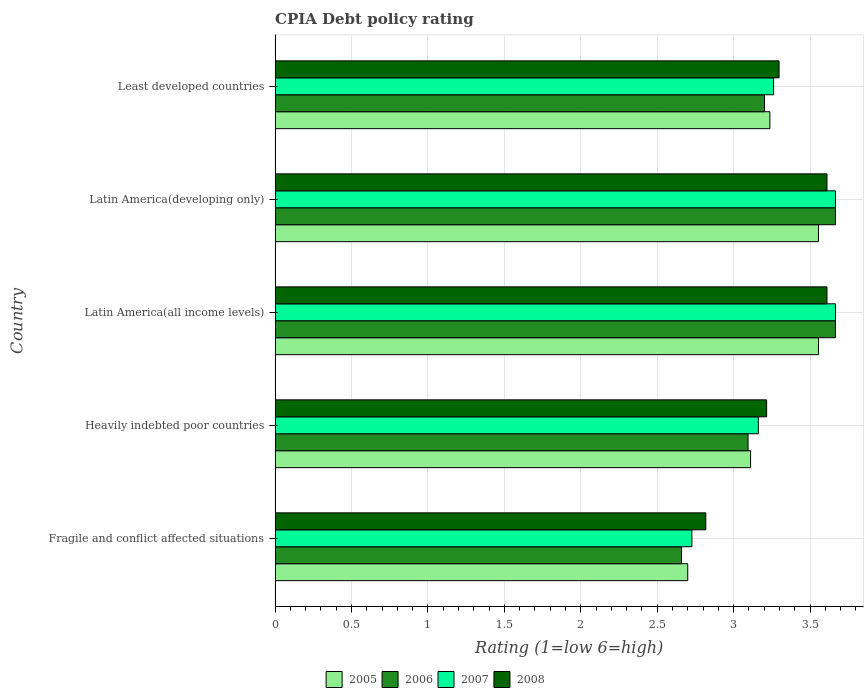How many different coloured bars are there?
Give a very brief answer. 4. How many groups of bars are there?
Your response must be concise. 5. How many bars are there on the 1st tick from the top?
Give a very brief answer. 4. How many bars are there on the 2nd tick from the bottom?
Provide a short and direct response. 4. What is the label of the 2nd group of bars from the top?
Provide a succinct answer. Latin America(developing only). In how many cases, is the number of bars for a given country not equal to the number of legend labels?
Your answer should be very brief. 0. What is the CPIA rating in 2008 in Fragile and conflict affected situations?
Make the answer very short. 2.82. Across all countries, what is the maximum CPIA rating in 2005?
Make the answer very short. 3.56. Across all countries, what is the minimum CPIA rating in 2006?
Provide a succinct answer. 2.66. In which country was the CPIA rating in 2008 maximum?
Your response must be concise. Latin America(all income levels). In which country was the CPIA rating in 2007 minimum?
Your response must be concise. Fragile and conflict affected situations. What is the total CPIA rating in 2006 in the graph?
Ensure brevity in your answer.  16.29. What is the difference between the CPIA rating in 2008 in Latin America(developing only) and that in Least developed countries?
Keep it short and to the point. 0.31. What is the difference between the CPIA rating in 2006 in Heavily indebted poor countries and the CPIA rating in 2007 in Latin America(all income levels)?
Your answer should be compact. -0.57. What is the average CPIA rating in 2006 per country?
Your answer should be very brief. 3.26. What is the difference between the CPIA rating in 2005 and CPIA rating in 2007 in Latin America(developing only)?
Provide a short and direct response. -0.11. What is the ratio of the CPIA rating in 2005 in Fragile and conflict affected situations to that in Least developed countries?
Your answer should be very brief. 0.83. Is the difference between the CPIA rating in 2005 in Fragile and conflict affected situations and Least developed countries greater than the difference between the CPIA rating in 2007 in Fragile and conflict affected situations and Least developed countries?
Your answer should be compact. No. What is the difference between the highest and the second highest CPIA rating in 2008?
Give a very brief answer. 0. What is the difference between the highest and the lowest CPIA rating in 2007?
Provide a short and direct response. 0.94. Is the sum of the CPIA rating in 2006 in Fragile and conflict affected situations and Latin America(developing only) greater than the maximum CPIA rating in 2005 across all countries?
Provide a succinct answer. Yes. Is it the case that in every country, the sum of the CPIA rating in 2008 and CPIA rating in 2005 is greater than the sum of CPIA rating in 2006 and CPIA rating in 2007?
Your answer should be compact. No. Is it the case that in every country, the sum of the CPIA rating in 2008 and CPIA rating in 2007 is greater than the CPIA rating in 2005?
Offer a terse response. Yes. Are all the bars in the graph horizontal?
Your answer should be compact. Yes. Where does the legend appear in the graph?
Your answer should be very brief. Bottom center. How are the legend labels stacked?
Make the answer very short. Horizontal. What is the title of the graph?
Keep it short and to the point. CPIA Debt policy rating. What is the label or title of the Y-axis?
Make the answer very short. Country. What is the Rating (1=low 6=high) of 2006 in Fragile and conflict affected situations?
Keep it short and to the point. 2.66. What is the Rating (1=low 6=high) of 2007 in Fragile and conflict affected situations?
Keep it short and to the point. 2.73. What is the Rating (1=low 6=high) in 2008 in Fragile and conflict affected situations?
Give a very brief answer. 2.82. What is the Rating (1=low 6=high) in 2005 in Heavily indebted poor countries?
Give a very brief answer. 3.11. What is the Rating (1=low 6=high) of 2006 in Heavily indebted poor countries?
Provide a short and direct response. 3.09. What is the Rating (1=low 6=high) in 2007 in Heavily indebted poor countries?
Provide a short and direct response. 3.16. What is the Rating (1=low 6=high) of 2008 in Heavily indebted poor countries?
Offer a terse response. 3.22. What is the Rating (1=low 6=high) of 2005 in Latin America(all income levels)?
Make the answer very short. 3.56. What is the Rating (1=low 6=high) in 2006 in Latin America(all income levels)?
Offer a terse response. 3.67. What is the Rating (1=low 6=high) of 2007 in Latin America(all income levels)?
Give a very brief answer. 3.67. What is the Rating (1=low 6=high) of 2008 in Latin America(all income levels)?
Offer a very short reply. 3.61. What is the Rating (1=low 6=high) in 2005 in Latin America(developing only)?
Provide a short and direct response. 3.56. What is the Rating (1=low 6=high) of 2006 in Latin America(developing only)?
Make the answer very short. 3.67. What is the Rating (1=low 6=high) of 2007 in Latin America(developing only)?
Give a very brief answer. 3.67. What is the Rating (1=low 6=high) in 2008 in Latin America(developing only)?
Offer a very short reply. 3.61. What is the Rating (1=low 6=high) of 2005 in Least developed countries?
Offer a very short reply. 3.24. What is the Rating (1=low 6=high) in 2006 in Least developed countries?
Provide a short and direct response. 3.2. What is the Rating (1=low 6=high) in 2007 in Least developed countries?
Provide a short and direct response. 3.26. What is the Rating (1=low 6=high) in 2008 in Least developed countries?
Keep it short and to the point. 3.3. Across all countries, what is the maximum Rating (1=low 6=high) in 2005?
Ensure brevity in your answer.  3.56. Across all countries, what is the maximum Rating (1=low 6=high) in 2006?
Make the answer very short. 3.67. Across all countries, what is the maximum Rating (1=low 6=high) in 2007?
Ensure brevity in your answer.  3.67. Across all countries, what is the maximum Rating (1=low 6=high) of 2008?
Your answer should be compact. 3.61. Across all countries, what is the minimum Rating (1=low 6=high) in 2005?
Give a very brief answer. 2.7. Across all countries, what is the minimum Rating (1=low 6=high) in 2006?
Keep it short and to the point. 2.66. Across all countries, what is the minimum Rating (1=low 6=high) in 2007?
Your answer should be very brief. 2.73. Across all countries, what is the minimum Rating (1=low 6=high) in 2008?
Your response must be concise. 2.82. What is the total Rating (1=low 6=high) in 2005 in the graph?
Keep it short and to the point. 16.16. What is the total Rating (1=low 6=high) in 2006 in the graph?
Your answer should be very brief. 16.29. What is the total Rating (1=low 6=high) in 2007 in the graph?
Make the answer very short. 16.48. What is the total Rating (1=low 6=high) of 2008 in the graph?
Give a very brief answer. 16.55. What is the difference between the Rating (1=low 6=high) of 2005 in Fragile and conflict affected situations and that in Heavily indebted poor countries?
Your answer should be very brief. -0.41. What is the difference between the Rating (1=low 6=high) in 2006 in Fragile and conflict affected situations and that in Heavily indebted poor countries?
Offer a terse response. -0.44. What is the difference between the Rating (1=low 6=high) in 2007 in Fragile and conflict affected situations and that in Heavily indebted poor countries?
Provide a succinct answer. -0.43. What is the difference between the Rating (1=low 6=high) of 2008 in Fragile and conflict affected situations and that in Heavily indebted poor countries?
Provide a short and direct response. -0.4. What is the difference between the Rating (1=low 6=high) in 2005 in Fragile and conflict affected situations and that in Latin America(all income levels)?
Provide a succinct answer. -0.86. What is the difference between the Rating (1=low 6=high) of 2006 in Fragile and conflict affected situations and that in Latin America(all income levels)?
Ensure brevity in your answer.  -1.01. What is the difference between the Rating (1=low 6=high) of 2007 in Fragile and conflict affected situations and that in Latin America(all income levels)?
Offer a very short reply. -0.94. What is the difference between the Rating (1=low 6=high) of 2008 in Fragile and conflict affected situations and that in Latin America(all income levels)?
Make the answer very short. -0.79. What is the difference between the Rating (1=low 6=high) of 2005 in Fragile and conflict affected situations and that in Latin America(developing only)?
Your response must be concise. -0.86. What is the difference between the Rating (1=low 6=high) in 2006 in Fragile and conflict affected situations and that in Latin America(developing only)?
Your answer should be compact. -1.01. What is the difference between the Rating (1=low 6=high) in 2007 in Fragile and conflict affected situations and that in Latin America(developing only)?
Give a very brief answer. -0.94. What is the difference between the Rating (1=low 6=high) in 2008 in Fragile and conflict affected situations and that in Latin America(developing only)?
Make the answer very short. -0.79. What is the difference between the Rating (1=low 6=high) in 2005 in Fragile and conflict affected situations and that in Least developed countries?
Your answer should be very brief. -0.54. What is the difference between the Rating (1=low 6=high) in 2006 in Fragile and conflict affected situations and that in Least developed countries?
Your response must be concise. -0.54. What is the difference between the Rating (1=low 6=high) of 2007 in Fragile and conflict affected situations and that in Least developed countries?
Provide a short and direct response. -0.53. What is the difference between the Rating (1=low 6=high) of 2008 in Fragile and conflict affected situations and that in Least developed countries?
Your answer should be compact. -0.48. What is the difference between the Rating (1=low 6=high) in 2005 in Heavily indebted poor countries and that in Latin America(all income levels)?
Give a very brief answer. -0.44. What is the difference between the Rating (1=low 6=high) of 2006 in Heavily indebted poor countries and that in Latin America(all income levels)?
Ensure brevity in your answer.  -0.57. What is the difference between the Rating (1=low 6=high) in 2007 in Heavily indebted poor countries and that in Latin America(all income levels)?
Your answer should be very brief. -0.5. What is the difference between the Rating (1=low 6=high) in 2008 in Heavily indebted poor countries and that in Latin America(all income levels)?
Your answer should be very brief. -0.39. What is the difference between the Rating (1=low 6=high) in 2005 in Heavily indebted poor countries and that in Latin America(developing only)?
Give a very brief answer. -0.44. What is the difference between the Rating (1=low 6=high) in 2006 in Heavily indebted poor countries and that in Latin America(developing only)?
Offer a terse response. -0.57. What is the difference between the Rating (1=low 6=high) in 2007 in Heavily indebted poor countries and that in Latin America(developing only)?
Give a very brief answer. -0.5. What is the difference between the Rating (1=low 6=high) of 2008 in Heavily indebted poor countries and that in Latin America(developing only)?
Your answer should be very brief. -0.39. What is the difference between the Rating (1=low 6=high) in 2005 in Heavily indebted poor countries and that in Least developed countries?
Offer a terse response. -0.13. What is the difference between the Rating (1=low 6=high) of 2006 in Heavily indebted poor countries and that in Least developed countries?
Provide a short and direct response. -0.11. What is the difference between the Rating (1=low 6=high) of 2007 in Heavily indebted poor countries and that in Least developed countries?
Your response must be concise. -0.1. What is the difference between the Rating (1=low 6=high) in 2008 in Heavily indebted poor countries and that in Least developed countries?
Make the answer very short. -0.08. What is the difference between the Rating (1=low 6=high) in 2006 in Latin America(all income levels) and that in Latin America(developing only)?
Offer a terse response. 0. What is the difference between the Rating (1=low 6=high) of 2007 in Latin America(all income levels) and that in Latin America(developing only)?
Keep it short and to the point. 0. What is the difference between the Rating (1=low 6=high) of 2008 in Latin America(all income levels) and that in Latin America(developing only)?
Give a very brief answer. 0. What is the difference between the Rating (1=low 6=high) in 2005 in Latin America(all income levels) and that in Least developed countries?
Keep it short and to the point. 0.32. What is the difference between the Rating (1=low 6=high) in 2006 in Latin America(all income levels) and that in Least developed countries?
Your response must be concise. 0.46. What is the difference between the Rating (1=low 6=high) of 2007 in Latin America(all income levels) and that in Least developed countries?
Keep it short and to the point. 0.4. What is the difference between the Rating (1=low 6=high) in 2008 in Latin America(all income levels) and that in Least developed countries?
Your answer should be very brief. 0.31. What is the difference between the Rating (1=low 6=high) of 2005 in Latin America(developing only) and that in Least developed countries?
Your answer should be compact. 0.32. What is the difference between the Rating (1=low 6=high) in 2006 in Latin America(developing only) and that in Least developed countries?
Provide a short and direct response. 0.46. What is the difference between the Rating (1=low 6=high) of 2007 in Latin America(developing only) and that in Least developed countries?
Provide a succinct answer. 0.4. What is the difference between the Rating (1=low 6=high) of 2008 in Latin America(developing only) and that in Least developed countries?
Your answer should be very brief. 0.31. What is the difference between the Rating (1=low 6=high) in 2005 in Fragile and conflict affected situations and the Rating (1=low 6=high) in 2006 in Heavily indebted poor countries?
Give a very brief answer. -0.39. What is the difference between the Rating (1=low 6=high) of 2005 in Fragile and conflict affected situations and the Rating (1=low 6=high) of 2007 in Heavily indebted poor countries?
Your answer should be compact. -0.46. What is the difference between the Rating (1=low 6=high) of 2005 in Fragile and conflict affected situations and the Rating (1=low 6=high) of 2008 in Heavily indebted poor countries?
Offer a very short reply. -0.52. What is the difference between the Rating (1=low 6=high) of 2006 in Fragile and conflict affected situations and the Rating (1=low 6=high) of 2007 in Heavily indebted poor countries?
Give a very brief answer. -0.5. What is the difference between the Rating (1=low 6=high) of 2006 in Fragile and conflict affected situations and the Rating (1=low 6=high) of 2008 in Heavily indebted poor countries?
Offer a terse response. -0.56. What is the difference between the Rating (1=low 6=high) in 2007 in Fragile and conflict affected situations and the Rating (1=low 6=high) in 2008 in Heavily indebted poor countries?
Keep it short and to the point. -0.49. What is the difference between the Rating (1=low 6=high) in 2005 in Fragile and conflict affected situations and the Rating (1=low 6=high) in 2006 in Latin America(all income levels)?
Offer a very short reply. -0.97. What is the difference between the Rating (1=low 6=high) of 2005 in Fragile and conflict affected situations and the Rating (1=low 6=high) of 2007 in Latin America(all income levels)?
Offer a terse response. -0.97. What is the difference between the Rating (1=low 6=high) of 2005 in Fragile and conflict affected situations and the Rating (1=low 6=high) of 2008 in Latin America(all income levels)?
Offer a very short reply. -0.91. What is the difference between the Rating (1=low 6=high) in 2006 in Fragile and conflict affected situations and the Rating (1=low 6=high) in 2007 in Latin America(all income levels)?
Provide a short and direct response. -1.01. What is the difference between the Rating (1=low 6=high) in 2006 in Fragile and conflict affected situations and the Rating (1=low 6=high) in 2008 in Latin America(all income levels)?
Give a very brief answer. -0.95. What is the difference between the Rating (1=low 6=high) of 2007 in Fragile and conflict affected situations and the Rating (1=low 6=high) of 2008 in Latin America(all income levels)?
Offer a terse response. -0.88. What is the difference between the Rating (1=low 6=high) of 2005 in Fragile and conflict affected situations and the Rating (1=low 6=high) of 2006 in Latin America(developing only)?
Make the answer very short. -0.97. What is the difference between the Rating (1=low 6=high) in 2005 in Fragile and conflict affected situations and the Rating (1=low 6=high) in 2007 in Latin America(developing only)?
Give a very brief answer. -0.97. What is the difference between the Rating (1=low 6=high) of 2005 in Fragile and conflict affected situations and the Rating (1=low 6=high) of 2008 in Latin America(developing only)?
Ensure brevity in your answer.  -0.91. What is the difference between the Rating (1=low 6=high) in 2006 in Fragile and conflict affected situations and the Rating (1=low 6=high) in 2007 in Latin America(developing only)?
Provide a short and direct response. -1.01. What is the difference between the Rating (1=low 6=high) of 2006 in Fragile and conflict affected situations and the Rating (1=low 6=high) of 2008 in Latin America(developing only)?
Provide a succinct answer. -0.95. What is the difference between the Rating (1=low 6=high) of 2007 in Fragile and conflict affected situations and the Rating (1=low 6=high) of 2008 in Latin America(developing only)?
Offer a terse response. -0.88. What is the difference between the Rating (1=low 6=high) in 2005 in Fragile and conflict affected situations and the Rating (1=low 6=high) in 2006 in Least developed countries?
Provide a succinct answer. -0.5. What is the difference between the Rating (1=low 6=high) in 2005 in Fragile and conflict affected situations and the Rating (1=low 6=high) in 2007 in Least developed countries?
Make the answer very short. -0.56. What is the difference between the Rating (1=low 6=high) of 2005 in Fragile and conflict affected situations and the Rating (1=low 6=high) of 2008 in Least developed countries?
Offer a terse response. -0.6. What is the difference between the Rating (1=low 6=high) of 2006 in Fragile and conflict affected situations and the Rating (1=low 6=high) of 2007 in Least developed countries?
Ensure brevity in your answer.  -0.6. What is the difference between the Rating (1=low 6=high) in 2006 in Fragile and conflict affected situations and the Rating (1=low 6=high) in 2008 in Least developed countries?
Keep it short and to the point. -0.64. What is the difference between the Rating (1=low 6=high) in 2007 in Fragile and conflict affected situations and the Rating (1=low 6=high) in 2008 in Least developed countries?
Give a very brief answer. -0.57. What is the difference between the Rating (1=low 6=high) of 2005 in Heavily indebted poor countries and the Rating (1=low 6=high) of 2006 in Latin America(all income levels)?
Keep it short and to the point. -0.56. What is the difference between the Rating (1=low 6=high) in 2005 in Heavily indebted poor countries and the Rating (1=low 6=high) in 2007 in Latin America(all income levels)?
Ensure brevity in your answer.  -0.56. What is the difference between the Rating (1=low 6=high) of 2006 in Heavily indebted poor countries and the Rating (1=low 6=high) of 2007 in Latin America(all income levels)?
Offer a terse response. -0.57. What is the difference between the Rating (1=low 6=high) in 2006 in Heavily indebted poor countries and the Rating (1=low 6=high) in 2008 in Latin America(all income levels)?
Ensure brevity in your answer.  -0.52. What is the difference between the Rating (1=low 6=high) in 2007 in Heavily indebted poor countries and the Rating (1=low 6=high) in 2008 in Latin America(all income levels)?
Your answer should be very brief. -0.45. What is the difference between the Rating (1=low 6=high) in 2005 in Heavily indebted poor countries and the Rating (1=low 6=high) in 2006 in Latin America(developing only)?
Your answer should be very brief. -0.56. What is the difference between the Rating (1=low 6=high) in 2005 in Heavily indebted poor countries and the Rating (1=low 6=high) in 2007 in Latin America(developing only)?
Your answer should be compact. -0.56. What is the difference between the Rating (1=low 6=high) of 2006 in Heavily indebted poor countries and the Rating (1=low 6=high) of 2007 in Latin America(developing only)?
Your answer should be compact. -0.57. What is the difference between the Rating (1=low 6=high) of 2006 in Heavily indebted poor countries and the Rating (1=low 6=high) of 2008 in Latin America(developing only)?
Offer a terse response. -0.52. What is the difference between the Rating (1=low 6=high) of 2007 in Heavily indebted poor countries and the Rating (1=low 6=high) of 2008 in Latin America(developing only)?
Give a very brief answer. -0.45. What is the difference between the Rating (1=low 6=high) of 2005 in Heavily indebted poor countries and the Rating (1=low 6=high) of 2006 in Least developed countries?
Provide a succinct answer. -0.09. What is the difference between the Rating (1=low 6=high) in 2005 in Heavily indebted poor countries and the Rating (1=low 6=high) in 2007 in Least developed countries?
Your response must be concise. -0.15. What is the difference between the Rating (1=low 6=high) in 2005 in Heavily indebted poor countries and the Rating (1=low 6=high) in 2008 in Least developed countries?
Provide a succinct answer. -0.19. What is the difference between the Rating (1=low 6=high) of 2006 in Heavily indebted poor countries and the Rating (1=low 6=high) of 2007 in Least developed countries?
Ensure brevity in your answer.  -0.17. What is the difference between the Rating (1=low 6=high) in 2006 in Heavily indebted poor countries and the Rating (1=low 6=high) in 2008 in Least developed countries?
Ensure brevity in your answer.  -0.2. What is the difference between the Rating (1=low 6=high) in 2007 in Heavily indebted poor countries and the Rating (1=low 6=high) in 2008 in Least developed countries?
Your answer should be very brief. -0.14. What is the difference between the Rating (1=low 6=high) in 2005 in Latin America(all income levels) and the Rating (1=low 6=high) in 2006 in Latin America(developing only)?
Offer a very short reply. -0.11. What is the difference between the Rating (1=low 6=high) in 2005 in Latin America(all income levels) and the Rating (1=low 6=high) in 2007 in Latin America(developing only)?
Provide a short and direct response. -0.11. What is the difference between the Rating (1=low 6=high) in 2005 in Latin America(all income levels) and the Rating (1=low 6=high) in 2008 in Latin America(developing only)?
Provide a succinct answer. -0.06. What is the difference between the Rating (1=low 6=high) in 2006 in Latin America(all income levels) and the Rating (1=low 6=high) in 2008 in Latin America(developing only)?
Ensure brevity in your answer.  0.06. What is the difference between the Rating (1=low 6=high) in 2007 in Latin America(all income levels) and the Rating (1=low 6=high) in 2008 in Latin America(developing only)?
Provide a succinct answer. 0.06. What is the difference between the Rating (1=low 6=high) of 2005 in Latin America(all income levels) and the Rating (1=low 6=high) of 2006 in Least developed countries?
Provide a succinct answer. 0.35. What is the difference between the Rating (1=low 6=high) in 2005 in Latin America(all income levels) and the Rating (1=low 6=high) in 2007 in Least developed countries?
Make the answer very short. 0.29. What is the difference between the Rating (1=low 6=high) of 2005 in Latin America(all income levels) and the Rating (1=low 6=high) of 2008 in Least developed countries?
Keep it short and to the point. 0.26. What is the difference between the Rating (1=low 6=high) in 2006 in Latin America(all income levels) and the Rating (1=low 6=high) in 2007 in Least developed countries?
Your answer should be compact. 0.4. What is the difference between the Rating (1=low 6=high) in 2006 in Latin America(all income levels) and the Rating (1=low 6=high) in 2008 in Least developed countries?
Your response must be concise. 0.37. What is the difference between the Rating (1=low 6=high) of 2007 in Latin America(all income levels) and the Rating (1=low 6=high) of 2008 in Least developed countries?
Keep it short and to the point. 0.37. What is the difference between the Rating (1=low 6=high) in 2005 in Latin America(developing only) and the Rating (1=low 6=high) in 2006 in Least developed countries?
Provide a succinct answer. 0.35. What is the difference between the Rating (1=low 6=high) of 2005 in Latin America(developing only) and the Rating (1=low 6=high) of 2007 in Least developed countries?
Provide a succinct answer. 0.29. What is the difference between the Rating (1=low 6=high) in 2005 in Latin America(developing only) and the Rating (1=low 6=high) in 2008 in Least developed countries?
Your answer should be very brief. 0.26. What is the difference between the Rating (1=low 6=high) in 2006 in Latin America(developing only) and the Rating (1=low 6=high) in 2007 in Least developed countries?
Your response must be concise. 0.4. What is the difference between the Rating (1=low 6=high) of 2006 in Latin America(developing only) and the Rating (1=low 6=high) of 2008 in Least developed countries?
Your answer should be very brief. 0.37. What is the difference between the Rating (1=low 6=high) in 2007 in Latin America(developing only) and the Rating (1=low 6=high) in 2008 in Least developed countries?
Provide a succinct answer. 0.37. What is the average Rating (1=low 6=high) in 2005 per country?
Your answer should be very brief. 3.23. What is the average Rating (1=low 6=high) of 2006 per country?
Ensure brevity in your answer.  3.26. What is the average Rating (1=low 6=high) of 2007 per country?
Offer a very short reply. 3.3. What is the average Rating (1=low 6=high) in 2008 per country?
Ensure brevity in your answer.  3.31. What is the difference between the Rating (1=low 6=high) in 2005 and Rating (1=low 6=high) in 2006 in Fragile and conflict affected situations?
Your response must be concise. 0.04. What is the difference between the Rating (1=low 6=high) in 2005 and Rating (1=low 6=high) in 2007 in Fragile and conflict affected situations?
Ensure brevity in your answer.  -0.03. What is the difference between the Rating (1=low 6=high) of 2005 and Rating (1=low 6=high) of 2008 in Fragile and conflict affected situations?
Ensure brevity in your answer.  -0.12. What is the difference between the Rating (1=low 6=high) of 2006 and Rating (1=low 6=high) of 2007 in Fragile and conflict affected situations?
Your answer should be very brief. -0.07. What is the difference between the Rating (1=low 6=high) of 2006 and Rating (1=low 6=high) of 2008 in Fragile and conflict affected situations?
Your answer should be compact. -0.16. What is the difference between the Rating (1=low 6=high) in 2007 and Rating (1=low 6=high) in 2008 in Fragile and conflict affected situations?
Provide a short and direct response. -0.09. What is the difference between the Rating (1=low 6=high) in 2005 and Rating (1=low 6=high) in 2006 in Heavily indebted poor countries?
Ensure brevity in your answer.  0.02. What is the difference between the Rating (1=low 6=high) of 2005 and Rating (1=low 6=high) of 2007 in Heavily indebted poor countries?
Ensure brevity in your answer.  -0.05. What is the difference between the Rating (1=low 6=high) of 2005 and Rating (1=low 6=high) of 2008 in Heavily indebted poor countries?
Offer a very short reply. -0.11. What is the difference between the Rating (1=low 6=high) in 2006 and Rating (1=low 6=high) in 2007 in Heavily indebted poor countries?
Provide a succinct answer. -0.07. What is the difference between the Rating (1=low 6=high) in 2006 and Rating (1=low 6=high) in 2008 in Heavily indebted poor countries?
Give a very brief answer. -0.12. What is the difference between the Rating (1=low 6=high) of 2007 and Rating (1=low 6=high) of 2008 in Heavily indebted poor countries?
Give a very brief answer. -0.05. What is the difference between the Rating (1=low 6=high) in 2005 and Rating (1=low 6=high) in 2006 in Latin America(all income levels)?
Ensure brevity in your answer.  -0.11. What is the difference between the Rating (1=low 6=high) in 2005 and Rating (1=low 6=high) in 2007 in Latin America(all income levels)?
Offer a terse response. -0.11. What is the difference between the Rating (1=low 6=high) of 2005 and Rating (1=low 6=high) of 2008 in Latin America(all income levels)?
Give a very brief answer. -0.06. What is the difference between the Rating (1=low 6=high) in 2006 and Rating (1=low 6=high) in 2007 in Latin America(all income levels)?
Your answer should be compact. 0. What is the difference between the Rating (1=low 6=high) of 2006 and Rating (1=low 6=high) of 2008 in Latin America(all income levels)?
Keep it short and to the point. 0.06. What is the difference between the Rating (1=low 6=high) in 2007 and Rating (1=low 6=high) in 2008 in Latin America(all income levels)?
Provide a succinct answer. 0.06. What is the difference between the Rating (1=low 6=high) of 2005 and Rating (1=low 6=high) of 2006 in Latin America(developing only)?
Keep it short and to the point. -0.11. What is the difference between the Rating (1=low 6=high) in 2005 and Rating (1=low 6=high) in 2007 in Latin America(developing only)?
Keep it short and to the point. -0.11. What is the difference between the Rating (1=low 6=high) of 2005 and Rating (1=low 6=high) of 2008 in Latin America(developing only)?
Offer a terse response. -0.06. What is the difference between the Rating (1=low 6=high) in 2006 and Rating (1=low 6=high) in 2008 in Latin America(developing only)?
Your answer should be very brief. 0.06. What is the difference between the Rating (1=low 6=high) of 2007 and Rating (1=low 6=high) of 2008 in Latin America(developing only)?
Your answer should be very brief. 0.06. What is the difference between the Rating (1=low 6=high) in 2005 and Rating (1=low 6=high) in 2006 in Least developed countries?
Keep it short and to the point. 0.04. What is the difference between the Rating (1=low 6=high) of 2005 and Rating (1=low 6=high) of 2007 in Least developed countries?
Provide a short and direct response. -0.02. What is the difference between the Rating (1=low 6=high) of 2005 and Rating (1=low 6=high) of 2008 in Least developed countries?
Make the answer very short. -0.06. What is the difference between the Rating (1=low 6=high) in 2006 and Rating (1=low 6=high) in 2007 in Least developed countries?
Your answer should be compact. -0.06. What is the difference between the Rating (1=low 6=high) of 2006 and Rating (1=low 6=high) of 2008 in Least developed countries?
Provide a succinct answer. -0.1. What is the difference between the Rating (1=low 6=high) of 2007 and Rating (1=low 6=high) of 2008 in Least developed countries?
Your answer should be compact. -0.04. What is the ratio of the Rating (1=low 6=high) of 2005 in Fragile and conflict affected situations to that in Heavily indebted poor countries?
Provide a short and direct response. 0.87. What is the ratio of the Rating (1=low 6=high) in 2006 in Fragile and conflict affected situations to that in Heavily indebted poor countries?
Keep it short and to the point. 0.86. What is the ratio of the Rating (1=low 6=high) of 2007 in Fragile and conflict affected situations to that in Heavily indebted poor countries?
Provide a short and direct response. 0.86. What is the ratio of the Rating (1=low 6=high) in 2008 in Fragile and conflict affected situations to that in Heavily indebted poor countries?
Give a very brief answer. 0.88. What is the ratio of the Rating (1=low 6=high) in 2005 in Fragile and conflict affected situations to that in Latin America(all income levels)?
Offer a very short reply. 0.76. What is the ratio of the Rating (1=low 6=high) in 2006 in Fragile and conflict affected situations to that in Latin America(all income levels)?
Ensure brevity in your answer.  0.73. What is the ratio of the Rating (1=low 6=high) in 2007 in Fragile and conflict affected situations to that in Latin America(all income levels)?
Your answer should be compact. 0.74. What is the ratio of the Rating (1=low 6=high) in 2008 in Fragile and conflict affected situations to that in Latin America(all income levels)?
Your answer should be very brief. 0.78. What is the ratio of the Rating (1=low 6=high) of 2005 in Fragile and conflict affected situations to that in Latin America(developing only)?
Provide a short and direct response. 0.76. What is the ratio of the Rating (1=low 6=high) in 2006 in Fragile and conflict affected situations to that in Latin America(developing only)?
Your answer should be very brief. 0.73. What is the ratio of the Rating (1=low 6=high) of 2007 in Fragile and conflict affected situations to that in Latin America(developing only)?
Your answer should be very brief. 0.74. What is the ratio of the Rating (1=low 6=high) of 2008 in Fragile and conflict affected situations to that in Latin America(developing only)?
Keep it short and to the point. 0.78. What is the ratio of the Rating (1=low 6=high) in 2005 in Fragile and conflict affected situations to that in Least developed countries?
Give a very brief answer. 0.83. What is the ratio of the Rating (1=low 6=high) of 2006 in Fragile and conflict affected situations to that in Least developed countries?
Offer a terse response. 0.83. What is the ratio of the Rating (1=low 6=high) in 2007 in Fragile and conflict affected situations to that in Least developed countries?
Provide a short and direct response. 0.84. What is the ratio of the Rating (1=low 6=high) of 2008 in Fragile and conflict affected situations to that in Least developed countries?
Offer a very short reply. 0.85. What is the ratio of the Rating (1=low 6=high) of 2005 in Heavily indebted poor countries to that in Latin America(all income levels)?
Keep it short and to the point. 0.88. What is the ratio of the Rating (1=low 6=high) in 2006 in Heavily indebted poor countries to that in Latin America(all income levels)?
Ensure brevity in your answer.  0.84. What is the ratio of the Rating (1=low 6=high) of 2007 in Heavily indebted poor countries to that in Latin America(all income levels)?
Offer a terse response. 0.86. What is the ratio of the Rating (1=low 6=high) of 2008 in Heavily indebted poor countries to that in Latin America(all income levels)?
Provide a succinct answer. 0.89. What is the ratio of the Rating (1=low 6=high) in 2005 in Heavily indebted poor countries to that in Latin America(developing only)?
Offer a very short reply. 0.88. What is the ratio of the Rating (1=low 6=high) of 2006 in Heavily indebted poor countries to that in Latin America(developing only)?
Provide a succinct answer. 0.84. What is the ratio of the Rating (1=low 6=high) of 2007 in Heavily indebted poor countries to that in Latin America(developing only)?
Keep it short and to the point. 0.86. What is the ratio of the Rating (1=low 6=high) in 2008 in Heavily indebted poor countries to that in Latin America(developing only)?
Make the answer very short. 0.89. What is the ratio of the Rating (1=low 6=high) in 2005 in Heavily indebted poor countries to that in Least developed countries?
Offer a terse response. 0.96. What is the ratio of the Rating (1=low 6=high) of 2006 in Heavily indebted poor countries to that in Least developed countries?
Provide a short and direct response. 0.97. What is the ratio of the Rating (1=low 6=high) in 2007 in Heavily indebted poor countries to that in Least developed countries?
Ensure brevity in your answer.  0.97. What is the ratio of the Rating (1=low 6=high) in 2008 in Heavily indebted poor countries to that in Least developed countries?
Give a very brief answer. 0.98. What is the ratio of the Rating (1=low 6=high) in 2006 in Latin America(all income levels) to that in Latin America(developing only)?
Offer a terse response. 1. What is the ratio of the Rating (1=low 6=high) of 2007 in Latin America(all income levels) to that in Latin America(developing only)?
Keep it short and to the point. 1. What is the ratio of the Rating (1=low 6=high) of 2008 in Latin America(all income levels) to that in Latin America(developing only)?
Make the answer very short. 1. What is the ratio of the Rating (1=low 6=high) of 2005 in Latin America(all income levels) to that in Least developed countries?
Give a very brief answer. 1.1. What is the ratio of the Rating (1=low 6=high) of 2006 in Latin America(all income levels) to that in Least developed countries?
Make the answer very short. 1.15. What is the ratio of the Rating (1=low 6=high) of 2007 in Latin America(all income levels) to that in Least developed countries?
Provide a short and direct response. 1.12. What is the ratio of the Rating (1=low 6=high) of 2008 in Latin America(all income levels) to that in Least developed countries?
Your answer should be compact. 1.1. What is the ratio of the Rating (1=low 6=high) of 2005 in Latin America(developing only) to that in Least developed countries?
Provide a succinct answer. 1.1. What is the ratio of the Rating (1=low 6=high) in 2006 in Latin America(developing only) to that in Least developed countries?
Offer a terse response. 1.15. What is the ratio of the Rating (1=low 6=high) in 2007 in Latin America(developing only) to that in Least developed countries?
Your response must be concise. 1.12. What is the ratio of the Rating (1=low 6=high) in 2008 in Latin America(developing only) to that in Least developed countries?
Offer a terse response. 1.1. What is the difference between the highest and the second highest Rating (1=low 6=high) of 2005?
Offer a terse response. 0. What is the difference between the highest and the second highest Rating (1=low 6=high) in 2006?
Ensure brevity in your answer.  0. What is the difference between the highest and the second highest Rating (1=low 6=high) in 2007?
Offer a very short reply. 0. What is the difference between the highest and the lowest Rating (1=low 6=high) in 2005?
Offer a terse response. 0.86. What is the difference between the highest and the lowest Rating (1=low 6=high) in 2006?
Your response must be concise. 1.01. What is the difference between the highest and the lowest Rating (1=low 6=high) in 2007?
Ensure brevity in your answer.  0.94. What is the difference between the highest and the lowest Rating (1=low 6=high) in 2008?
Your answer should be compact. 0.79. 